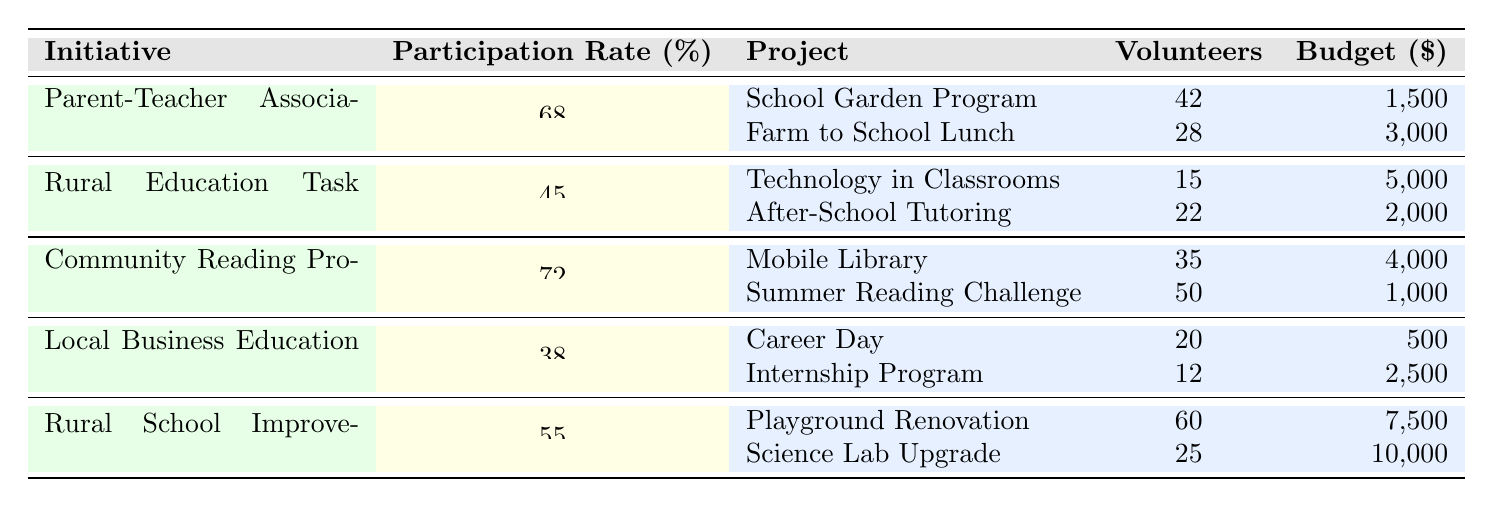What is the participation rate for the Community Reading Program? The Community Reading Program has a participation rate of 72%, as indicated in the table under the "Participation Rate" column.
Answer: 72% Which initiative has the highest number of volunteers for a single project? The Playground Renovation project under the Rural School Improvement Committee has the highest number of volunteers with 60, as compared to other projects listed in the table.
Answer: 60 How many volunteers participated in the Farm to School Lunch project? The Farm to School Lunch project has 28 volunteers, noted in the corresponding row of the table.
Answer: 28 What is the total budget for projects under the Rural Education Task Force? The sum of the budgets for Technology in Classrooms ($5000) and After-School Tutoring ($2000) is $7000, calculated as 5000 + 2000.
Answer: 7000 Is the participation rate for the Local Business Education Partnership higher than that of the Rural School Improvement Committee? The participation rate of the Local Business Education Partnership is 38%, while the Rural School Improvement Committee has a participation rate of 55%. Since 38% is less than 55%, the statement is false.
Answer: No What is the average participation rate of all initiatives listed in the table? The participation rates are 68, 45, 72, 38, and 55. Adding these gives 68 + 45 + 72 + 38 + 55 = 278. Dividing by the number of initiatives (5) gives an average of 278 / 5 = 55.6.
Answer: 55.6 Which project under the Community Reading Program had the lowest budget? Within the Community Reading Program, the Summer Reading Challenge has the lowest budget at $1000 compared to the Mobile Library's budget of $4000.
Answer: $1000 How many total volunteers were involved in the Rural School Improvement Committee's projects? The two projects under the Rural School Improvement Committee have 60 volunteers (Playground Renovation) and 25 volunteers (Science Lab Upgrade). Summing these gives 60 + 25 = 85 total volunteers.
Answer: 85 Are there more projects under the Rural Education Task Force than the Parent-Teacher Association? Both the Rural Education Task Force and the Parent-Teacher Association have 2 projects listed each, so there are not more projects under one than the other.
Answer: No What is the combined budget for all the projects under the Parent-Teacher Association? The combined budget is calculated by adding the School Garden Program budget ($1500) and the Farm to School Lunch budget ($3000), resulting in $1500 + $3000 = $4500.
Answer: $4500 